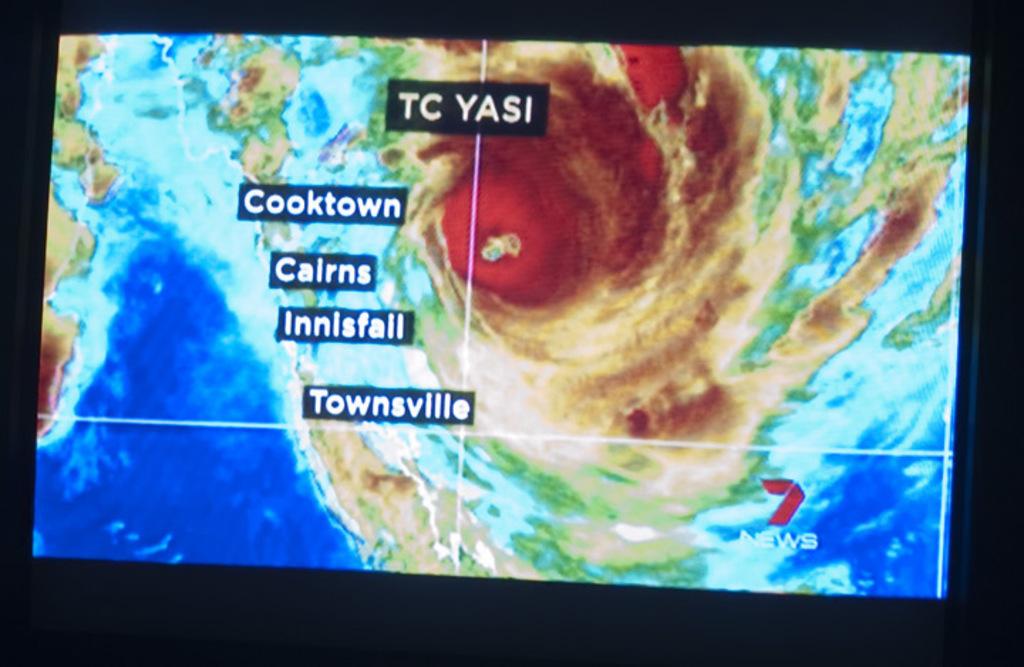That is the name after "tc"?
Offer a terse response. Yasi. 